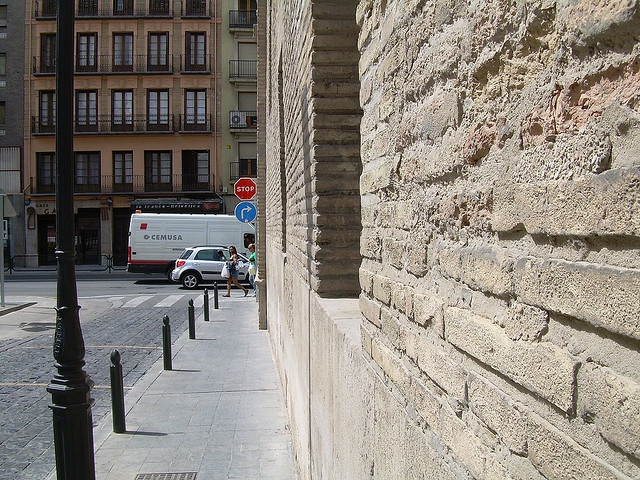Describe the objects in this image and their specific colors. I can see truck in black, darkgray, white, and gray tones, car in black, gray, darkgray, and white tones, people in black, gray, maroon, and darkgray tones, stop sign in black, maroon, brown, and lightpink tones, and people in black, darkgray, gray, and lightgray tones in this image. 